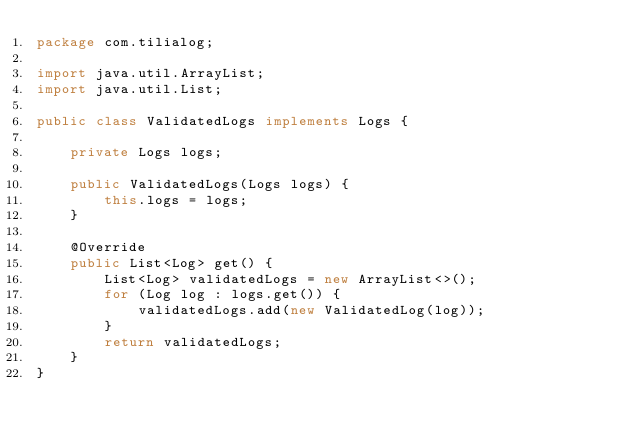Convert code to text. <code><loc_0><loc_0><loc_500><loc_500><_Java_>package com.tilialog;

import java.util.ArrayList;
import java.util.List;

public class ValidatedLogs implements Logs {

    private Logs logs;

    public ValidatedLogs(Logs logs) {
        this.logs = logs;
    }

    @Override
    public List<Log> get() {
        List<Log> validatedLogs = new ArrayList<>();
        for (Log log : logs.get()) {
            validatedLogs.add(new ValidatedLog(log));
        }
        return validatedLogs;
    }
}
</code> 